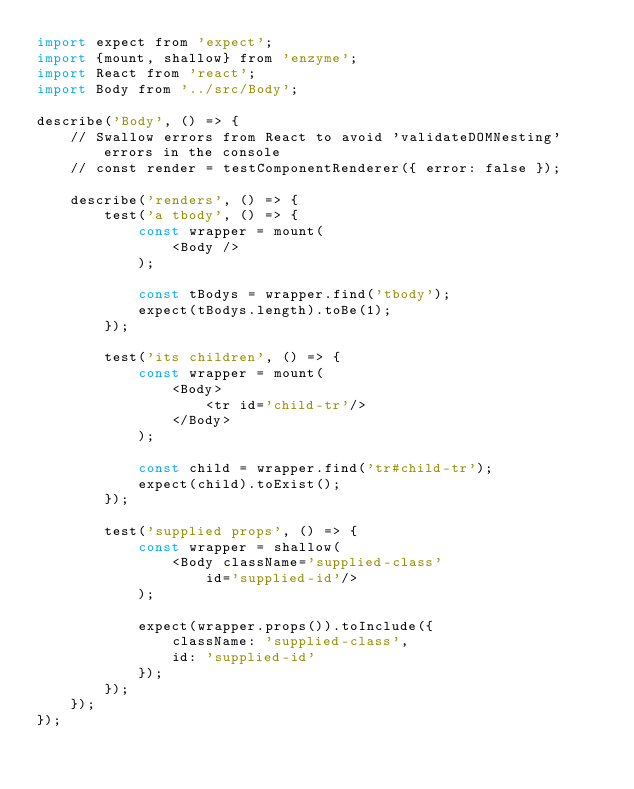<code> <loc_0><loc_0><loc_500><loc_500><_JavaScript_>import expect from 'expect';
import {mount, shallow} from 'enzyme';
import React from 'react';
import Body from '../src/Body';

describe('Body', () => {
    // Swallow errors from React to avoid 'validateDOMNesting' errors in the console
    // const render = testComponentRenderer({ error: false });

    describe('renders', () => {
        test('a tbody', () => {
            const wrapper = mount(
                <Body />
            );

            const tBodys = wrapper.find('tbody');
            expect(tBodys.length).toBe(1);
        });

        test('its children', () => {
            const wrapper = mount(
                <Body>
                    <tr id='child-tr'/>
                </Body>
            );

            const child = wrapper.find('tr#child-tr');
            expect(child).toExist();
        });

        test('supplied props', () => {
            const wrapper = shallow(
                <Body className='supplied-class'
                    id='supplied-id'/>
            );

            expect(wrapper.props()).toInclude({
                className: 'supplied-class',
                id: 'supplied-id'
            });
        });
    });
});
</code> 